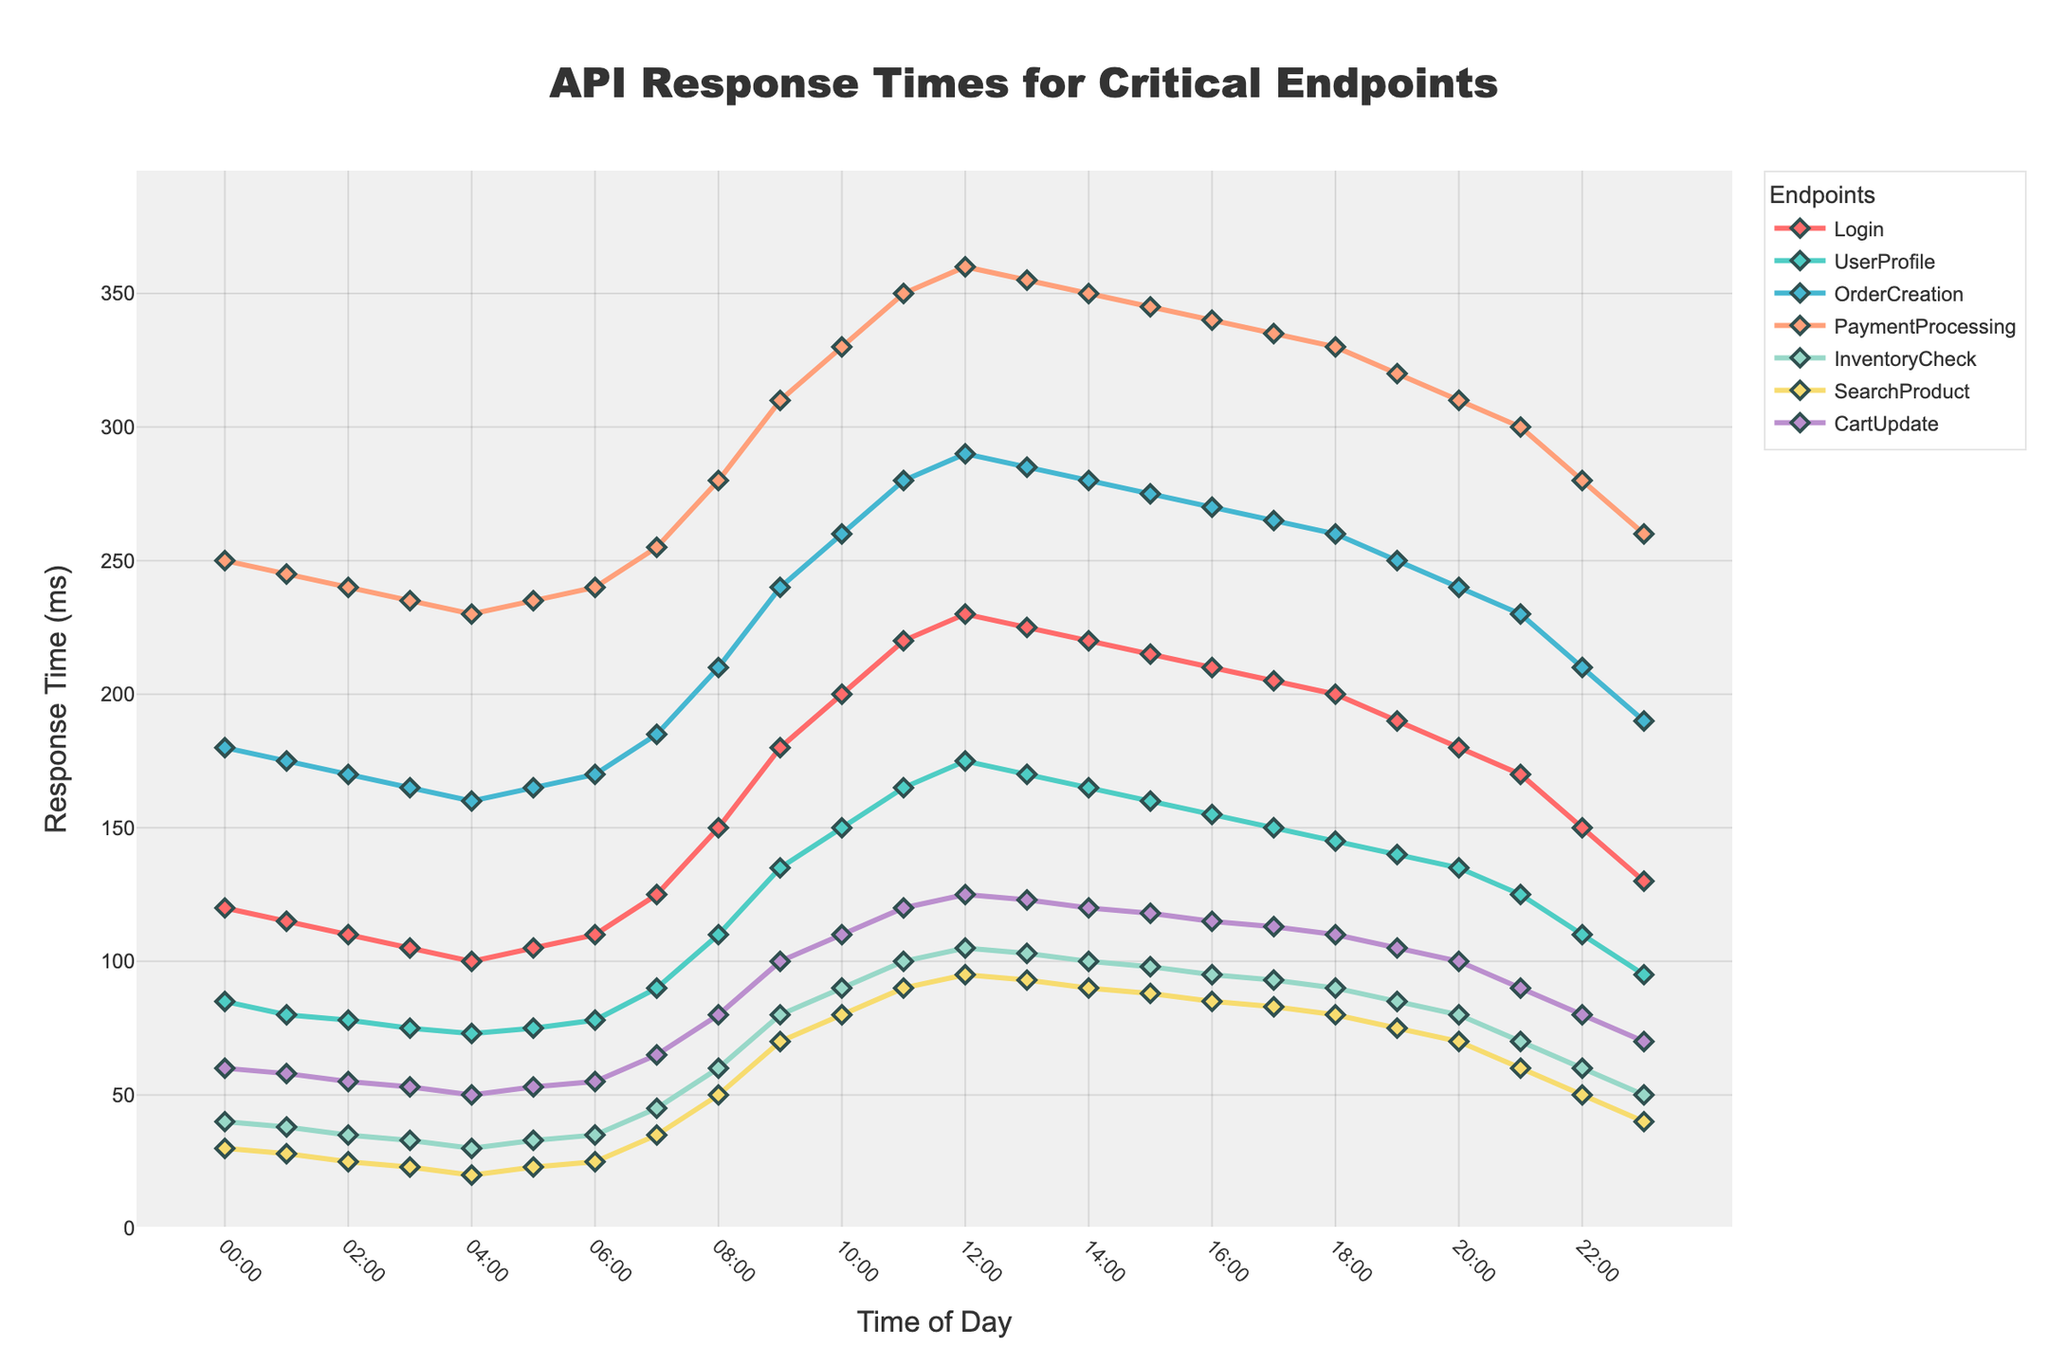Which endpoint has the highest response time at 09:00? At 09:00, the response time for each endpoint is plotted. The highest value at this timestamp is for PaymentProcessing with a response time of 310 ms.
Answer: PaymentProcessing Which endpoint shows the most improvement in response time from 12:00 to 23:00? To determine improvement, we check the endpoints for the difference from 12:00 to 23:00. PaymentProcessing decreases from 360 ms to 260 ms, an improvement of 100 ms, which is the largest change.
Answer: PaymentProcessing What is the average response time for InventoryCheck between 00:00 and 12:00? Sum the response times for InventoryCheck at each hour from 00:00 to 12:00 and divide by the number of hours. (40+38+35+33+30+33+35+45+60+80+90+100+105)/13 = 65.4 ms
Answer: 65.4 ms Which endpoint has consistently the lowest response time throughout the day? Reviewing the entire chart, it's evident that SearchProduct consistently displays the lowest response times, peaking at only 95 ms at 12:00.
Answer: SearchProduct At what time do the response times for Login and UserProfile converge closest together? To find this, identify the time where the difference between Login and UserProfile response times is smallest, which occurs at 13:00 where Login is 225 ms and UserProfile is 170 ms (difference of 55 ms).
Answer: 13:00 What's the difference in response time for OrderCreation between its peak and lowest values? Identifying the peak and lowest values for OrderCreation, we find the peak at 12:00 (290 ms) and the lowest at 04:00 (160 ms), making the difference 290 - 160 = 130 ms.
Answer: 130 ms How does the trend for CartUpdate from 00:00 to 23:00 visually compare to that of UserProfile? CartUpdate shows a gradual increase and then a gradual decrease, whereas UserProfile shows a consistent increase from early hours, peaking at mid-day, and then a gradual decrease. The trends are somewhat similar but UserProfile has a more pronounced peak.
Answer: Similar but different peaks 